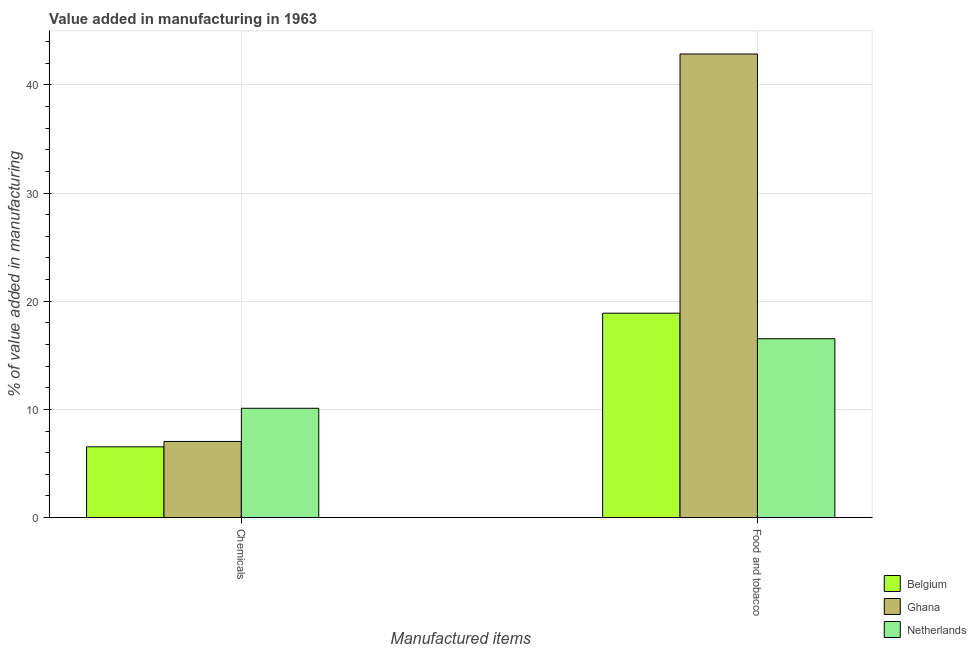How many different coloured bars are there?
Your response must be concise. 3. How many groups of bars are there?
Offer a very short reply. 2. How many bars are there on the 1st tick from the left?
Make the answer very short. 3. What is the label of the 2nd group of bars from the left?
Your answer should be very brief. Food and tobacco. What is the value added by  manufacturing chemicals in Netherlands?
Keep it short and to the point. 10.1. Across all countries, what is the maximum value added by  manufacturing chemicals?
Your response must be concise. 10.1. Across all countries, what is the minimum value added by manufacturing food and tobacco?
Keep it short and to the point. 16.53. What is the total value added by manufacturing food and tobacco in the graph?
Offer a terse response. 78.28. What is the difference between the value added by  manufacturing chemicals in Netherlands and that in Ghana?
Ensure brevity in your answer.  3.07. What is the difference between the value added by manufacturing food and tobacco in Netherlands and the value added by  manufacturing chemicals in Belgium?
Your answer should be very brief. 10. What is the average value added by manufacturing food and tobacco per country?
Provide a short and direct response. 26.09. What is the difference between the value added by manufacturing food and tobacco and value added by  manufacturing chemicals in Ghana?
Your response must be concise. 35.82. What is the ratio of the value added by  manufacturing chemicals in Ghana to that in Belgium?
Provide a succinct answer. 1.08. In how many countries, is the value added by manufacturing food and tobacco greater than the average value added by manufacturing food and tobacco taken over all countries?
Provide a succinct answer. 1. What does the 3rd bar from the right in Chemicals represents?
Your response must be concise. Belgium. How many bars are there?
Your answer should be very brief. 6. How many countries are there in the graph?
Keep it short and to the point. 3. Does the graph contain any zero values?
Ensure brevity in your answer.  No. How are the legend labels stacked?
Give a very brief answer. Vertical. What is the title of the graph?
Keep it short and to the point. Value added in manufacturing in 1963. What is the label or title of the X-axis?
Offer a very short reply. Manufactured items. What is the label or title of the Y-axis?
Keep it short and to the point. % of value added in manufacturing. What is the % of value added in manufacturing in Belgium in Chemicals?
Offer a very short reply. 6.54. What is the % of value added in manufacturing of Ghana in Chemicals?
Give a very brief answer. 7.04. What is the % of value added in manufacturing of Netherlands in Chemicals?
Provide a succinct answer. 10.1. What is the % of value added in manufacturing in Belgium in Food and tobacco?
Ensure brevity in your answer.  18.89. What is the % of value added in manufacturing in Ghana in Food and tobacco?
Provide a short and direct response. 42.86. What is the % of value added in manufacturing of Netherlands in Food and tobacco?
Offer a terse response. 16.53. Across all Manufactured items, what is the maximum % of value added in manufacturing in Belgium?
Give a very brief answer. 18.89. Across all Manufactured items, what is the maximum % of value added in manufacturing of Ghana?
Provide a short and direct response. 42.86. Across all Manufactured items, what is the maximum % of value added in manufacturing in Netherlands?
Your answer should be very brief. 16.53. Across all Manufactured items, what is the minimum % of value added in manufacturing of Belgium?
Ensure brevity in your answer.  6.54. Across all Manufactured items, what is the minimum % of value added in manufacturing of Ghana?
Provide a succinct answer. 7.04. Across all Manufactured items, what is the minimum % of value added in manufacturing of Netherlands?
Offer a terse response. 10.1. What is the total % of value added in manufacturing of Belgium in the graph?
Your response must be concise. 25.43. What is the total % of value added in manufacturing in Ghana in the graph?
Provide a succinct answer. 49.89. What is the total % of value added in manufacturing in Netherlands in the graph?
Give a very brief answer. 26.64. What is the difference between the % of value added in manufacturing of Belgium in Chemicals and that in Food and tobacco?
Provide a short and direct response. -12.36. What is the difference between the % of value added in manufacturing in Ghana in Chemicals and that in Food and tobacco?
Your response must be concise. -35.82. What is the difference between the % of value added in manufacturing of Netherlands in Chemicals and that in Food and tobacco?
Make the answer very short. -6.43. What is the difference between the % of value added in manufacturing of Belgium in Chemicals and the % of value added in manufacturing of Ghana in Food and tobacco?
Offer a terse response. -36.32. What is the difference between the % of value added in manufacturing in Belgium in Chemicals and the % of value added in manufacturing in Netherlands in Food and tobacco?
Give a very brief answer. -10. What is the difference between the % of value added in manufacturing in Ghana in Chemicals and the % of value added in manufacturing in Netherlands in Food and tobacco?
Your answer should be compact. -9.5. What is the average % of value added in manufacturing in Belgium per Manufactured items?
Your response must be concise. 12.72. What is the average % of value added in manufacturing in Ghana per Manufactured items?
Keep it short and to the point. 24.95. What is the average % of value added in manufacturing in Netherlands per Manufactured items?
Keep it short and to the point. 13.32. What is the difference between the % of value added in manufacturing of Belgium and % of value added in manufacturing of Ghana in Chemicals?
Offer a very short reply. -0.5. What is the difference between the % of value added in manufacturing of Belgium and % of value added in manufacturing of Netherlands in Chemicals?
Provide a succinct answer. -3.57. What is the difference between the % of value added in manufacturing in Ghana and % of value added in manufacturing in Netherlands in Chemicals?
Provide a short and direct response. -3.07. What is the difference between the % of value added in manufacturing in Belgium and % of value added in manufacturing in Ghana in Food and tobacco?
Offer a terse response. -23.96. What is the difference between the % of value added in manufacturing of Belgium and % of value added in manufacturing of Netherlands in Food and tobacco?
Give a very brief answer. 2.36. What is the difference between the % of value added in manufacturing of Ghana and % of value added in manufacturing of Netherlands in Food and tobacco?
Provide a short and direct response. 26.32. What is the ratio of the % of value added in manufacturing in Belgium in Chemicals to that in Food and tobacco?
Give a very brief answer. 0.35. What is the ratio of the % of value added in manufacturing of Ghana in Chemicals to that in Food and tobacco?
Give a very brief answer. 0.16. What is the ratio of the % of value added in manufacturing in Netherlands in Chemicals to that in Food and tobacco?
Your answer should be compact. 0.61. What is the difference between the highest and the second highest % of value added in manufacturing of Belgium?
Make the answer very short. 12.36. What is the difference between the highest and the second highest % of value added in manufacturing in Ghana?
Provide a short and direct response. 35.82. What is the difference between the highest and the second highest % of value added in manufacturing of Netherlands?
Offer a very short reply. 6.43. What is the difference between the highest and the lowest % of value added in manufacturing in Belgium?
Ensure brevity in your answer.  12.36. What is the difference between the highest and the lowest % of value added in manufacturing in Ghana?
Give a very brief answer. 35.82. What is the difference between the highest and the lowest % of value added in manufacturing of Netherlands?
Give a very brief answer. 6.43. 